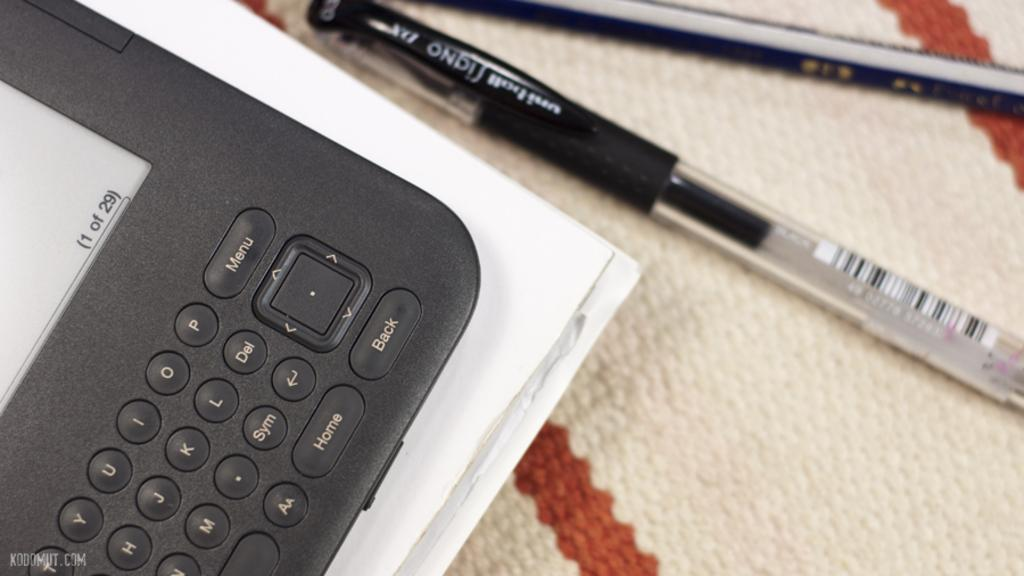<image>
Provide a brief description of the given image. The edge of a tablet is on a cloth with a Signa ink pen to it's right. 